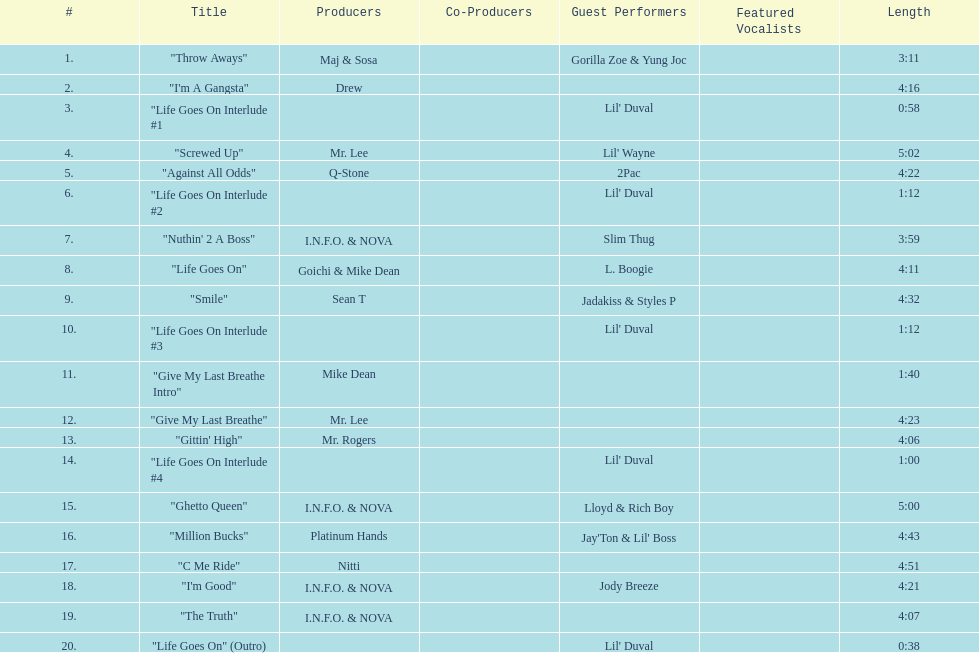How long is the longest track on the album? 5:02. 